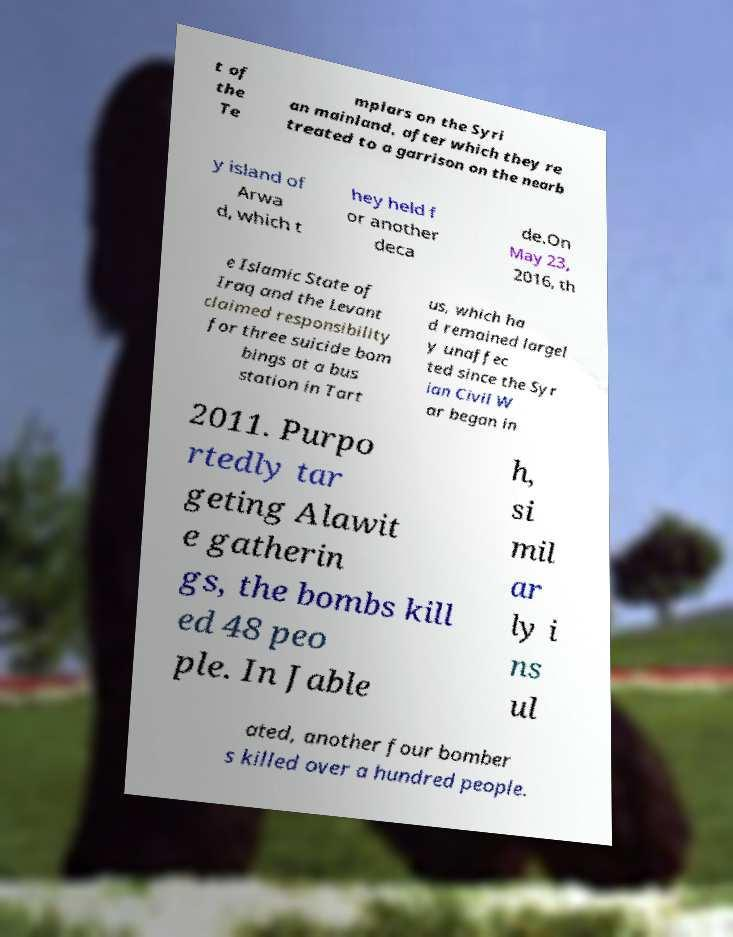I need the written content from this picture converted into text. Can you do that? t of the Te mplars on the Syri an mainland, after which they re treated to a garrison on the nearb y island of Arwa d, which t hey held f or another deca de.On May 23, 2016, th e Islamic State of Iraq and the Levant claimed responsibility for three suicide bom bings at a bus station in Tart us, which ha d remained largel y unaffec ted since the Syr ian Civil W ar began in 2011. Purpo rtedly tar geting Alawit e gatherin gs, the bombs kill ed 48 peo ple. In Jable h, si mil ar ly i ns ul ated, another four bomber s killed over a hundred people. 